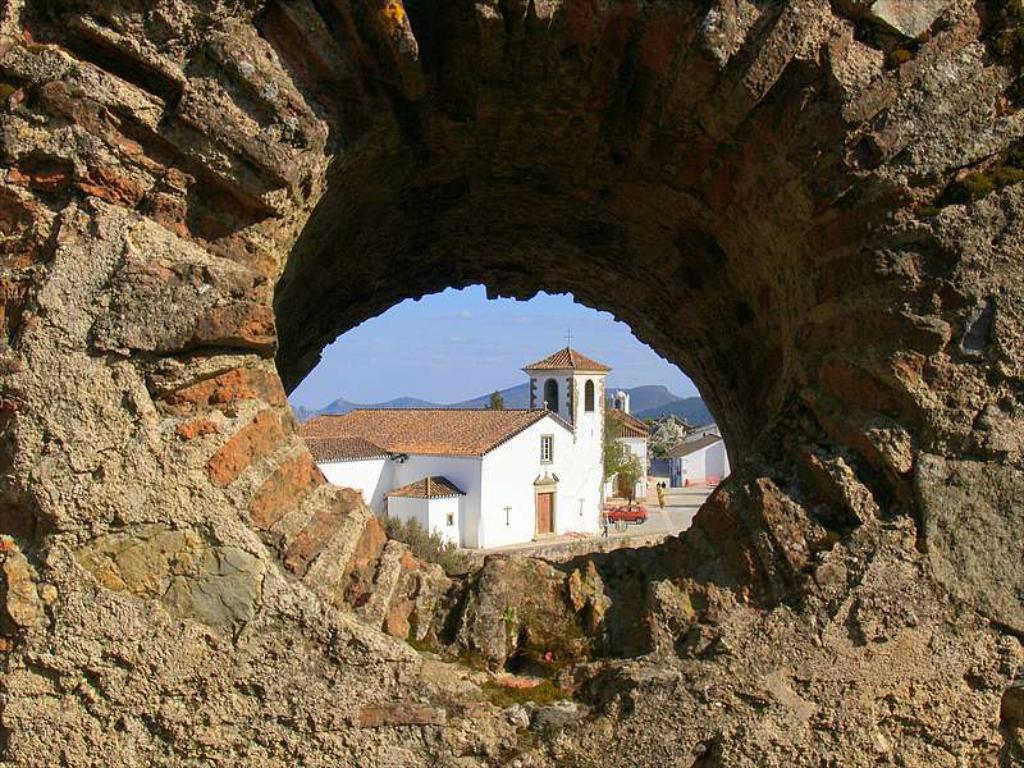Please provide a concise description of this image. In the picture we can see an old wall with a brick on it, we can see a round hole from it, we can see house building with roof top and near it, we can see some trees and behind it we can see some hills and sky. 